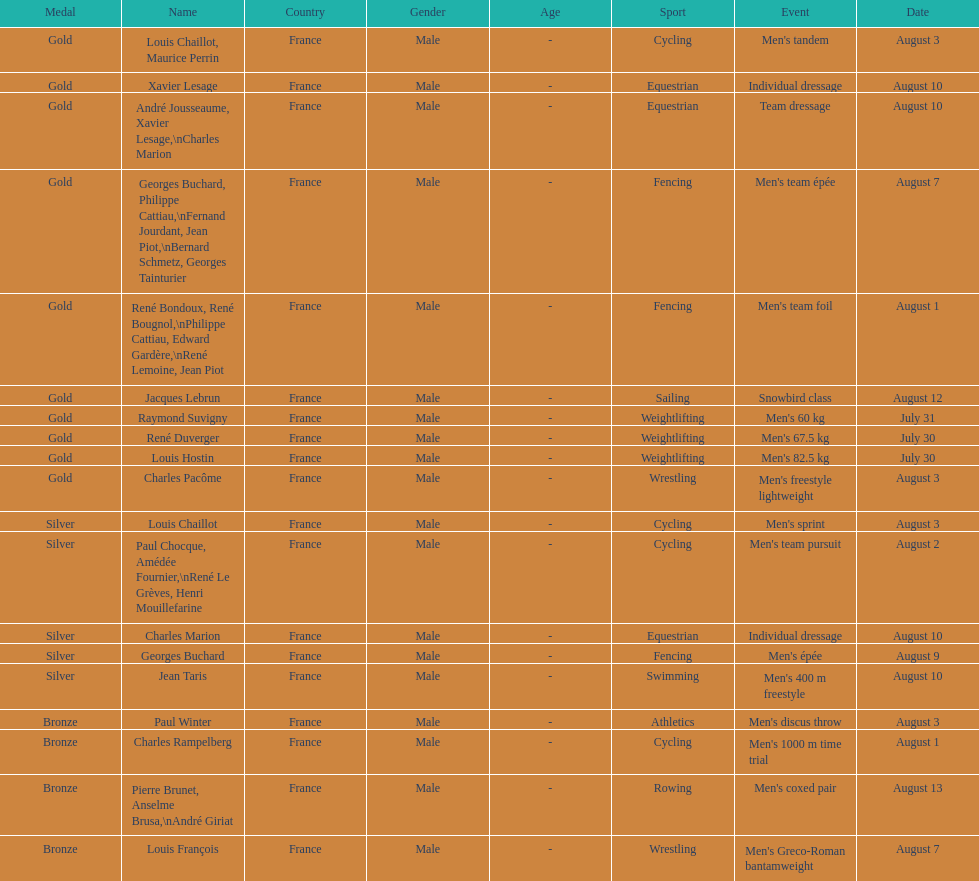How many medals were won after august 3? 9. 